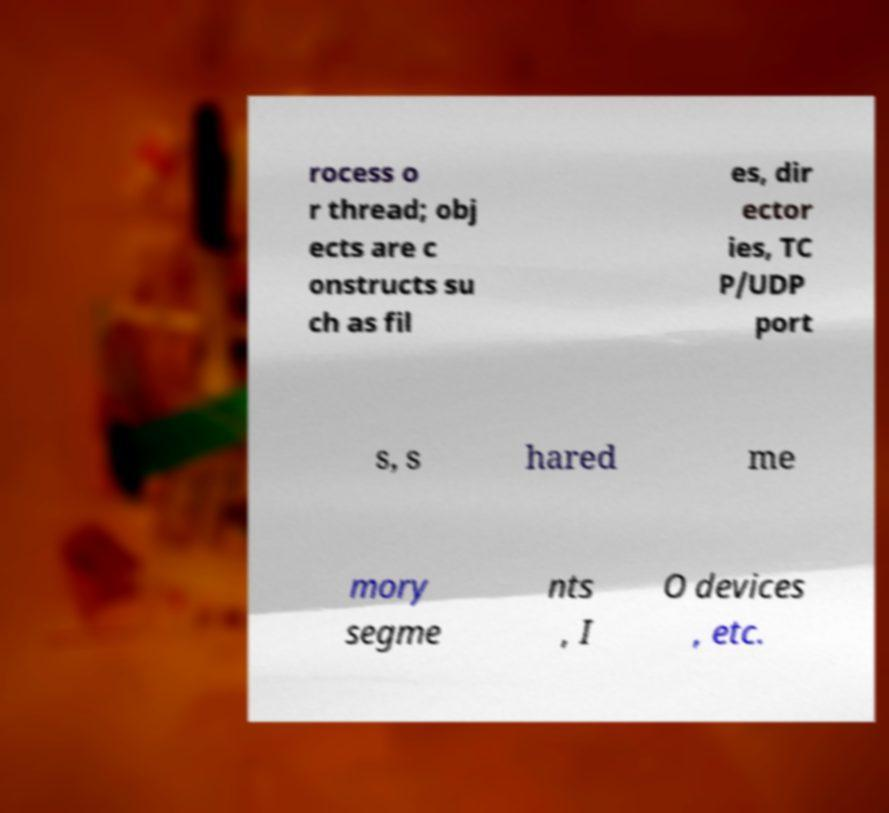For documentation purposes, I need the text within this image transcribed. Could you provide that? rocess o r thread; obj ects are c onstructs su ch as fil es, dir ector ies, TC P/UDP port s, s hared me mory segme nts , I O devices , etc. 